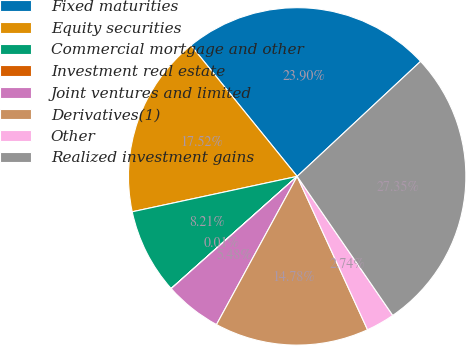<chart> <loc_0><loc_0><loc_500><loc_500><pie_chart><fcel>Fixed maturities<fcel>Equity securities<fcel>Commercial mortgage and other<fcel>Investment real estate<fcel>Joint ventures and limited<fcel>Derivatives(1)<fcel>Other<fcel>Realized investment gains<nl><fcel>23.9%<fcel>17.52%<fcel>8.21%<fcel>0.01%<fcel>5.48%<fcel>14.78%<fcel>2.74%<fcel>27.35%<nl></chart> 